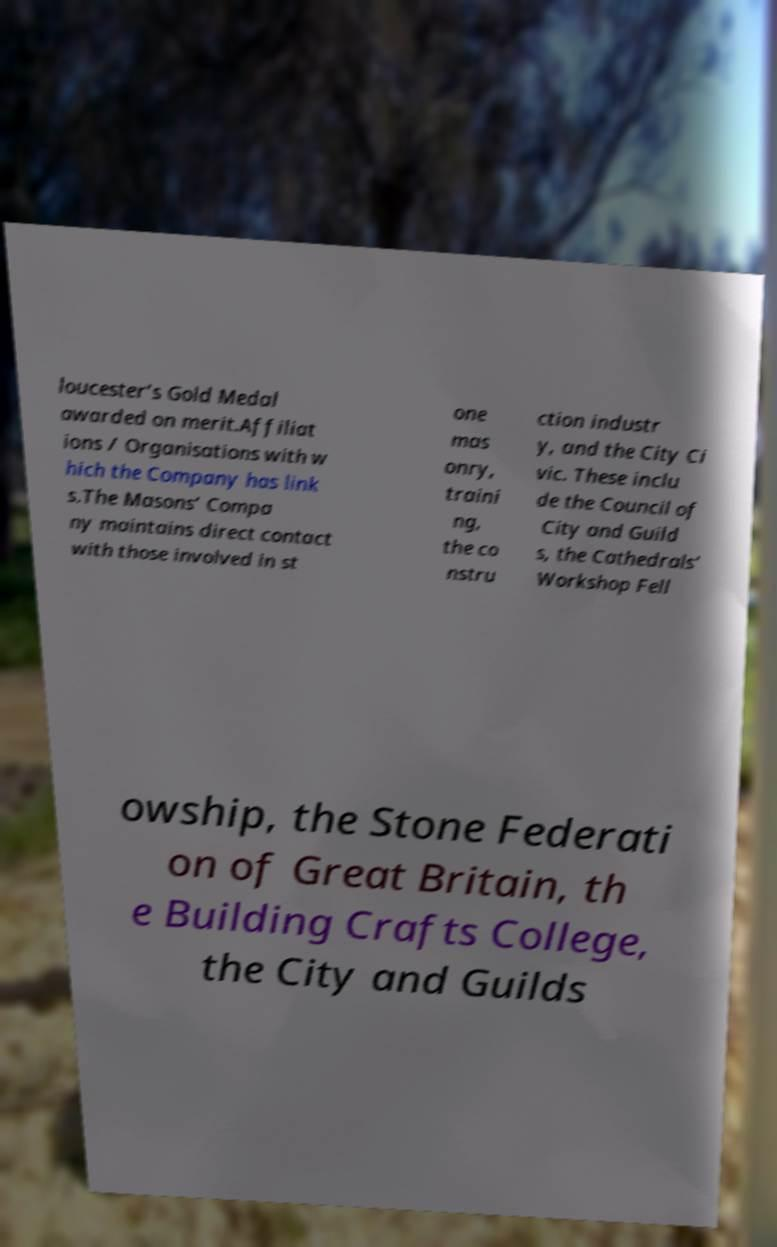Can you accurately transcribe the text from the provided image for me? loucester’s Gold Medal awarded on merit.Affiliat ions / Organisations with w hich the Company has link s.The Masons’ Compa ny maintains direct contact with those involved in st one mas onry, traini ng, the co nstru ction industr y, and the City Ci vic. These inclu de the Council of City and Guild s, the Cathedrals’ Workshop Fell owship, the Stone Federati on of Great Britain, th e Building Crafts College, the City and Guilds 